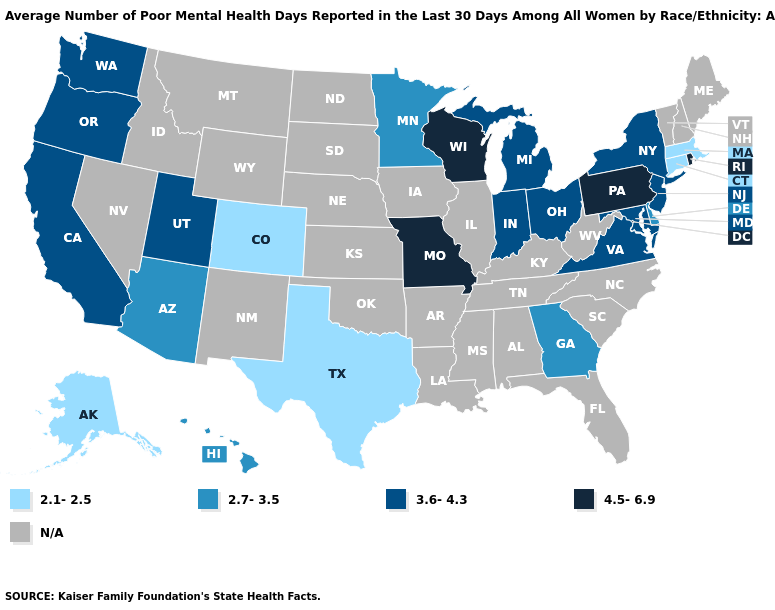What is the highest value in states that border New Hampshire?
Write a very short answer. 2.1-2.5. What is the highest value in the MidWest ?
Write a very short answer. 4.5-6.9. Which states hav the highest value in the Northeast?
Write a very short answer. Pennsylvania, Rhode Island. Name the states that have a value in the range N/A?
Concise answer only. Alabama, Arkansas, Florida, Idaho, Illinois, Iowa, Kansas, Kentucky, Louisiana, Maine, Mississippi, Montana, Nebraska, Nevada, New Hampshire, New Mexico, North Carolina, North Dakota, Oklahoma, South Carolina, South Dakota, Tennessee, Vermont, West Virginia, Wyoming. Does California have the lowest value in the USA?
Quick response, please. No. What is the value of New Hampshire?
Short answer required. N/A. Does the first symbol in the legend represent the smallest category?
Be succinct. Yes. What is the value of Iowa?
Be succinct. N/A. Name the states that have a value in the range N/A?
Answer briefly. Alabama, Arkansas, Florida, Idaho, Illinois, Iowa, Kansas, Kentucky, Louisiana, Maine, Mississippi, Montana, Nebraska, Nevada, New Hampshire, New Mexico, North Carolina, North Dakota, Oklahoma, South Carolina, South Dakota, Tennessee, Vermont, West Virginia, Wyoming. Among the states that border New Mexico , which have the highest value?
Be succinct. Utah. What is the value of South Carolina?
Concise answer only. N/A. Does the map have missing data?
Write a very short answer. Yes. How many symbols are there in the legend?
Keep it brief. 5. Name the states that have a value in the range 2.1-2.5?
Short answer required. Alaska, Colorado, Connecticut, Massachusetts, Texas. Name the states that have a value in the range 4.5-6.9?
Be succinct. Missouri, Pennsylvania, Rhode Island, Wisconsin. 